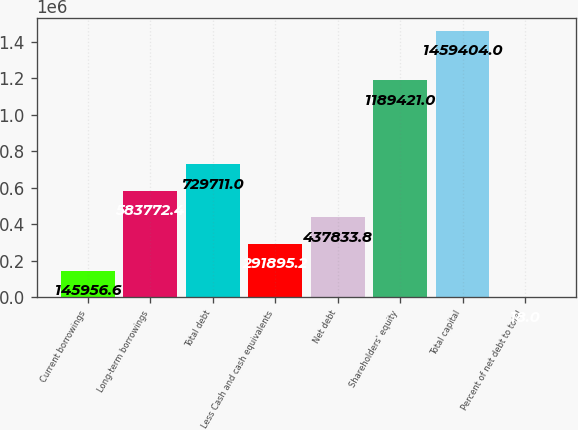Convert chart. <chart><loc_0><loc_0><loc_500><loc_500><bar_chart><fcel>Current borrowings<fcel>Long-term borrowings<fcel>Total debt<fcel>Less Cash and cash equivalents<fcel>Net debt<fcel>Shareholders' equity<fcel>Total capital<fcel>Percent of net debt to total<nl><fcel>145957<fcel>583772<fcel>729711<fcel>291895<fcel>437834<fcel>1.18942e+06<fcel>1.4594e+06<fcel>18<nl></chart> 